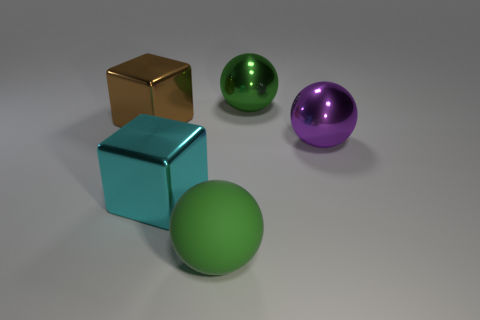Add 3 big cyan shiny things. How many objects exist? 8 Subtract all spheres. How many objects are left? 2 Add 4 big cyan things. How many big cyan things are left? 5 Add 1 big blocks. How many big blocks exist? 3 Subtract 0 brown spheres. How many objects are left? 5 Subtract all big cyan cubes. Subtract all big brown metallic things. How many objects are left? 3 